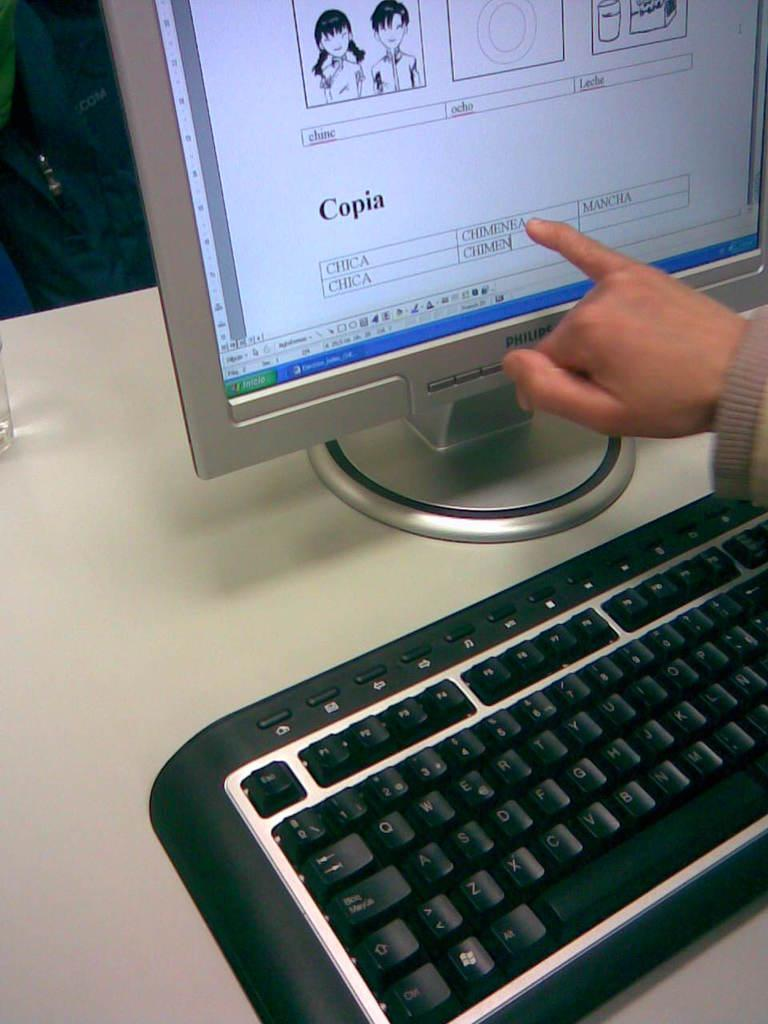<image>
Create a compact narrative representing the image presented. A person pointing at the word Chimenea on a computer screen. 